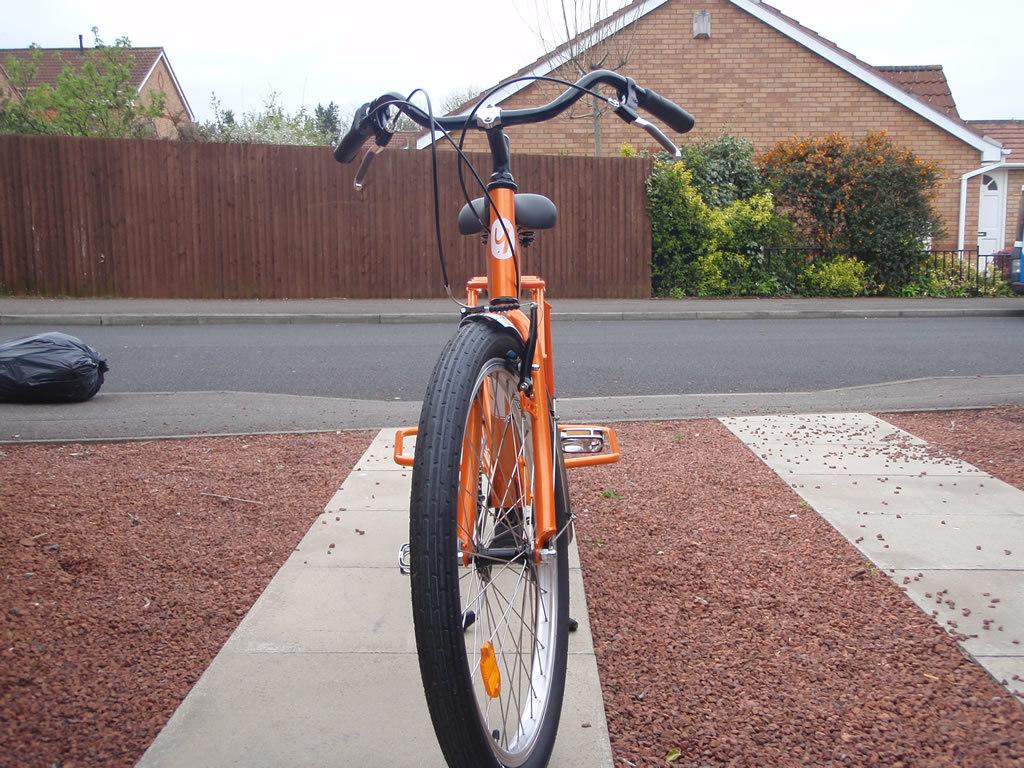What is the main subject in the center of the image? There is a bicycle in the center of the image. Where is the bicycle located? The bicycle is on the side of the road. What else can be seen on the road in the image? There is a bag on the road. What can be seen in the background of the image? There are buildings and trees in the background of the image. What type of wood is used to make the shoe in the image? There is no shoe present in the image, so it is not possible to determine the type of wood used to make it. 